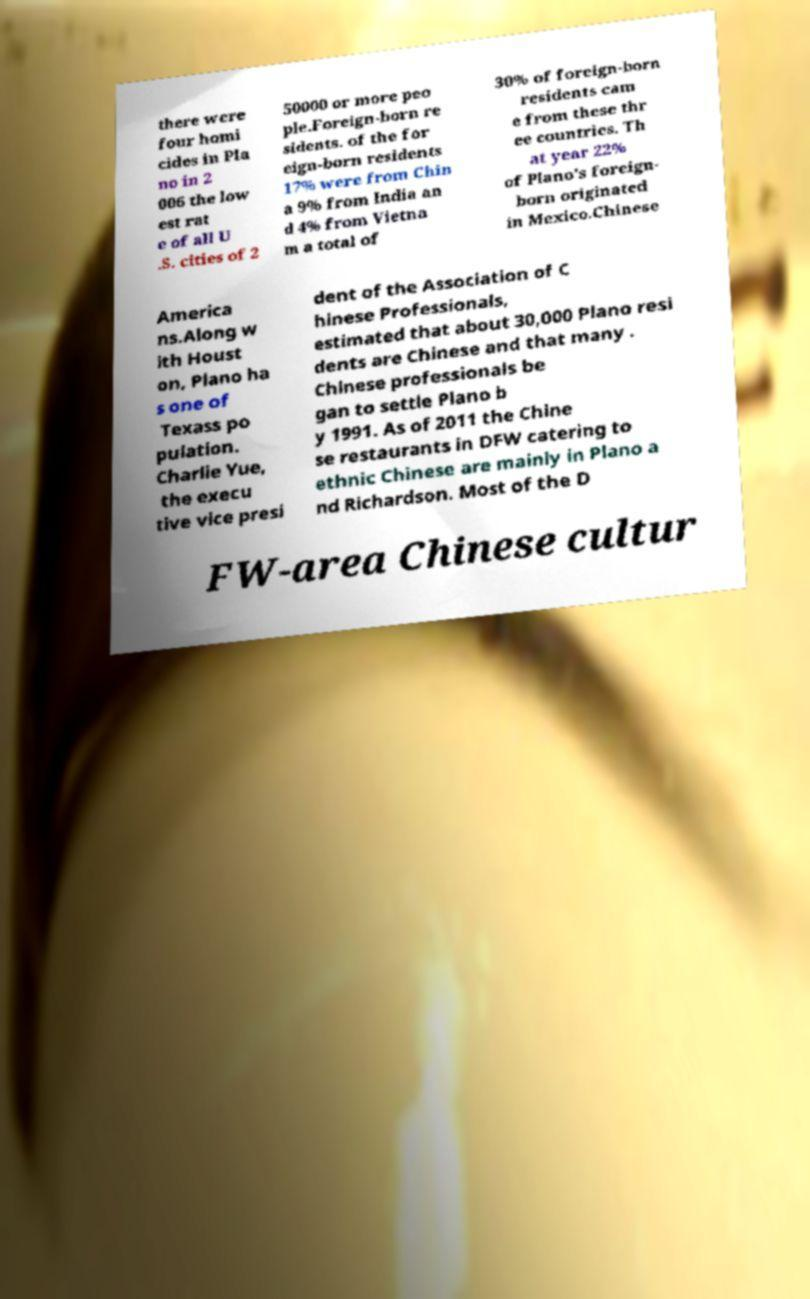I need the written content from this picture converted into text. Can you do that? there were four homi cides in Pla no in 2 006 the low est rat e of all U .S. cities of 2 50000 or more peo ple.Foreign-born re sidents. of the for eign-born residents 17% were from Chin a 9% from India an d 4% from Vietna m a total of 30% of foreign-born residents cam e from these thr ee countries. Th at year 22% of Plano's foreign- born originated in Mexico.Chinese America ns.Along w ith Houst on, Plano ha s one of Texass po pulation. Charlie Yue, the execu tive vice presi dent of the Association of C hinese Professionals, estimated that about 30,000 Plano resi dents are Chinese and that many . Chinese professionals be gan to settle Plano b y 1991. As of 2011 the Chine se restaurants in DFW catering to ethnic Chinese are mainly in Plano a nd Richardson. Most of the D FW-area Chinese cultur 